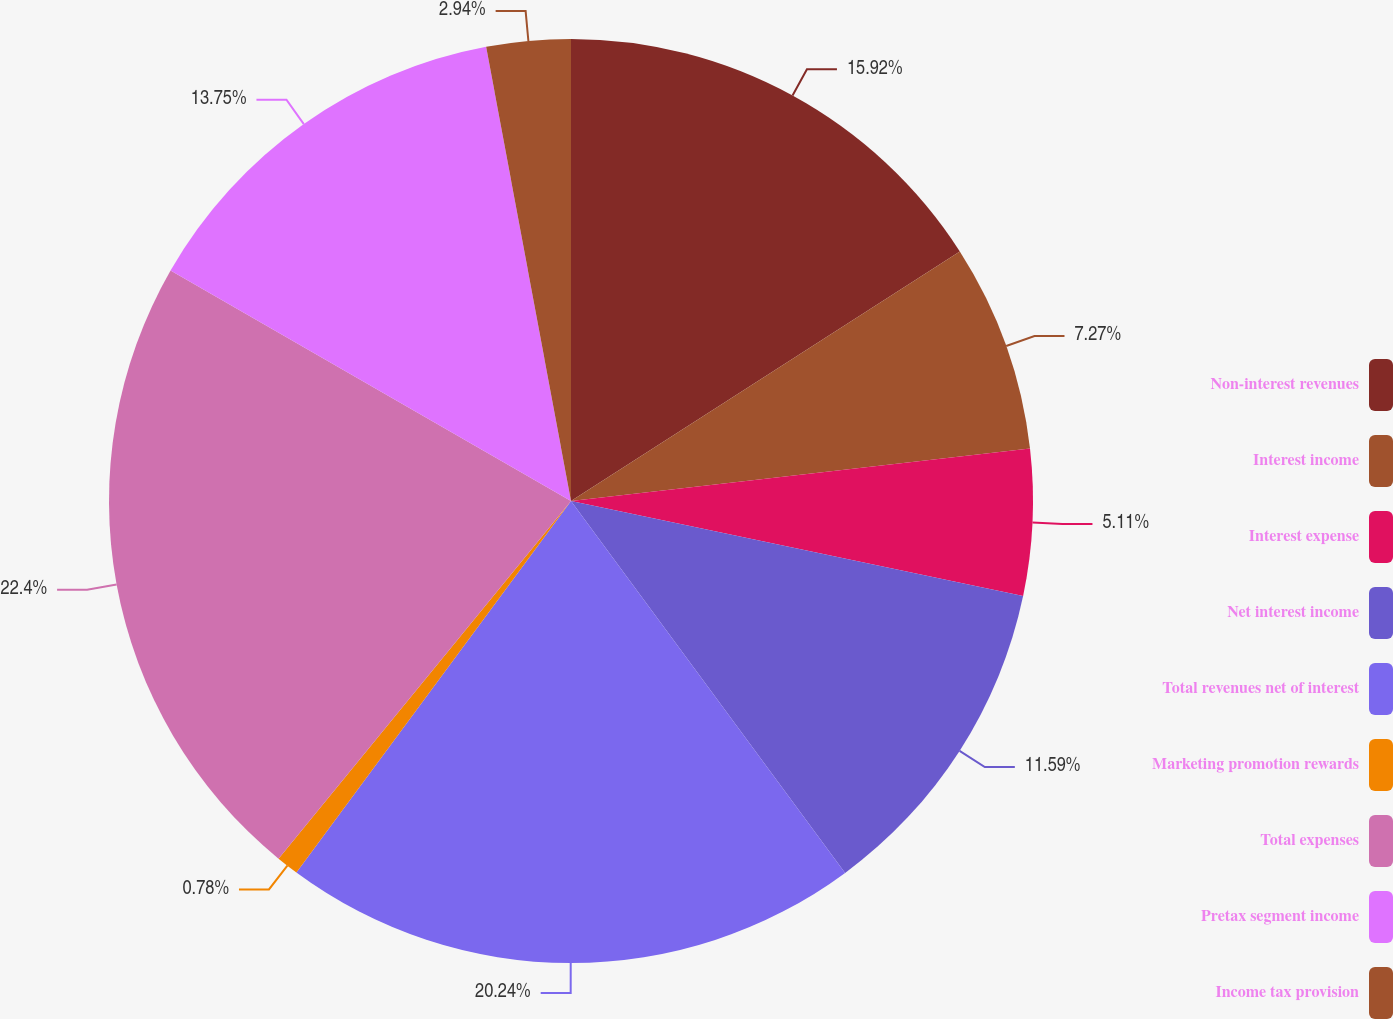<chart> <loc_0><loc_0><loc_500><loc_500><pie_chart><fcel>Non-interest revenues<fcel>Interest income<fcel>Interest expense<fcel>Net interest income<fcel>Total revenues net of interest<fcel>Marketing promotion rewards<fcel>Total expenses<fcel>Pretax segment income<fcel>Income tax provision<nl><fcel>15.92%<fcel>7.27%<fcel>5.11%<fcel>11.59%<fcel>20.24%<fcel>0.78%<fcel>22.4%<fcel>13.75%<fcel>2.94%<nl></chart> 